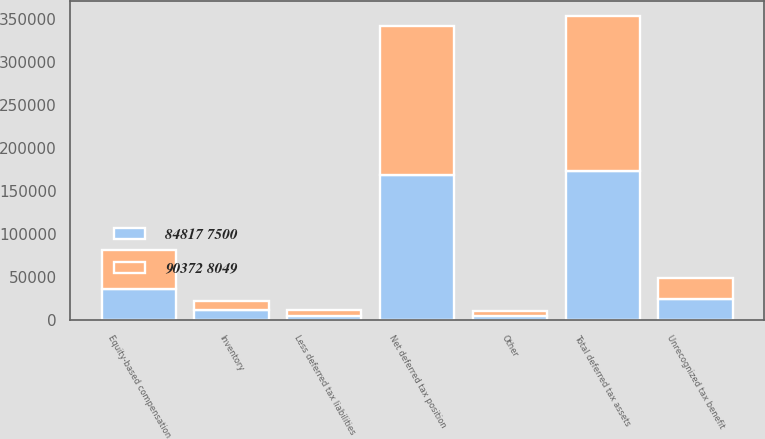<chart> <loc_0><loc_0><loc_500><loc_500><stacked_bar_chart><ecel><fcel>Equity-based compensation<fcel>Inventory<fcel>Unrecognized tax benefit<fcel>Other<fcel>Total deferred tax assets<fcel>Less deferred tax liabilities<fcel>Net deferred tax position<nl><fcel>90372 8049<fcel>46257<fcel>11153<fcel>24485<fcel>5847<fcel>180059<fcel>7371<fcel>172688<nl><fcel>84817 7500<fcel>35298<fcel>11099<fcel>23784<fcel>4200<fcel>172802<fcel>4290<fcel>168512<nl></chart> 